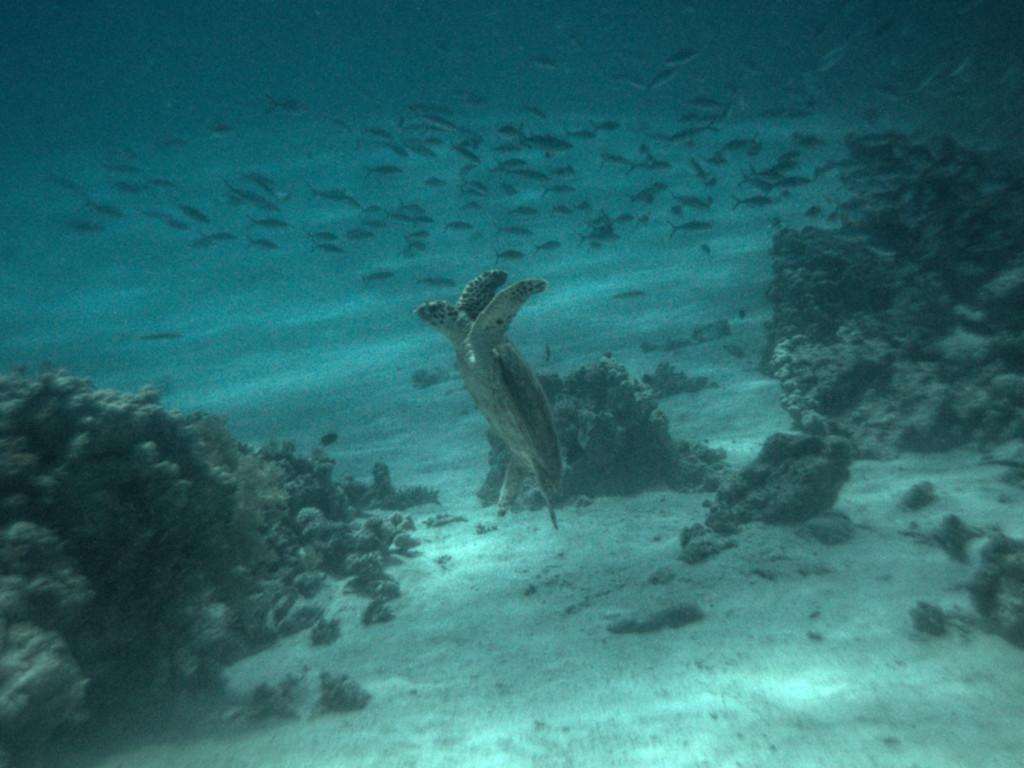Could you give a brief overview of what you see in this image? In this image we can see many fishes and a turtle in the water. There are few rocks in the image. 